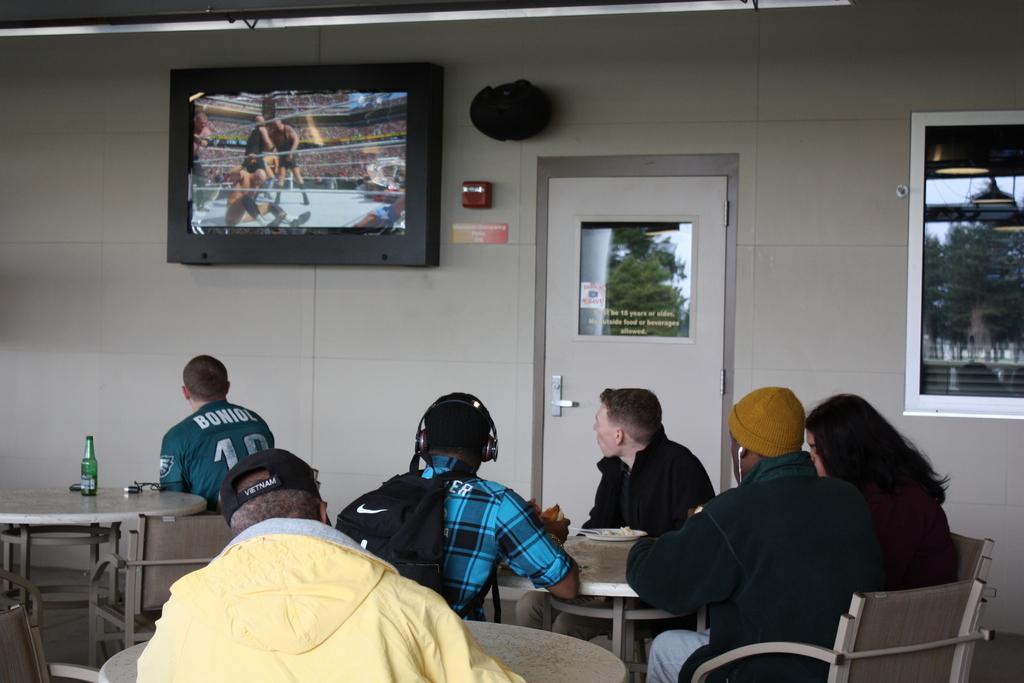How would you summarize this image in a sentence or two? In this image we can see few people sitting on the chairs, a person is wearing a backpack and headphones, there are few tables, there is a bottle on the table and a plate on other table, there is a television and few objects on the wall, there is a door, on the glass we can see the reflection of trees, lights, stairs and the sky. 